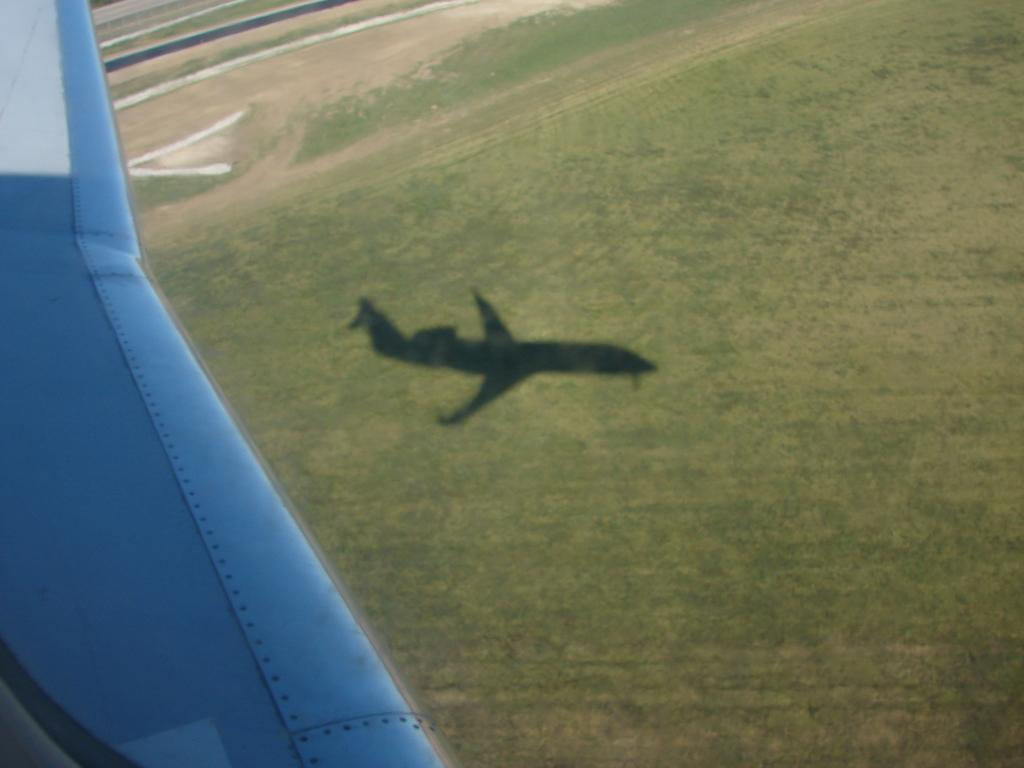What type of view is shown in the image? The image is an aerial view from a flight. What color is the sky in the image? The sky appears blue in the image. What can be seen on the ground in the image? The ground is visible in the image, and there is grass on it. Is there any indication of the flight's presence in the image? Yes, there is a shadow of the flight on the ground. Can you see any cows grazing on the grass in the image? There are no cows visible in the image; it only shows grass on the ground. 